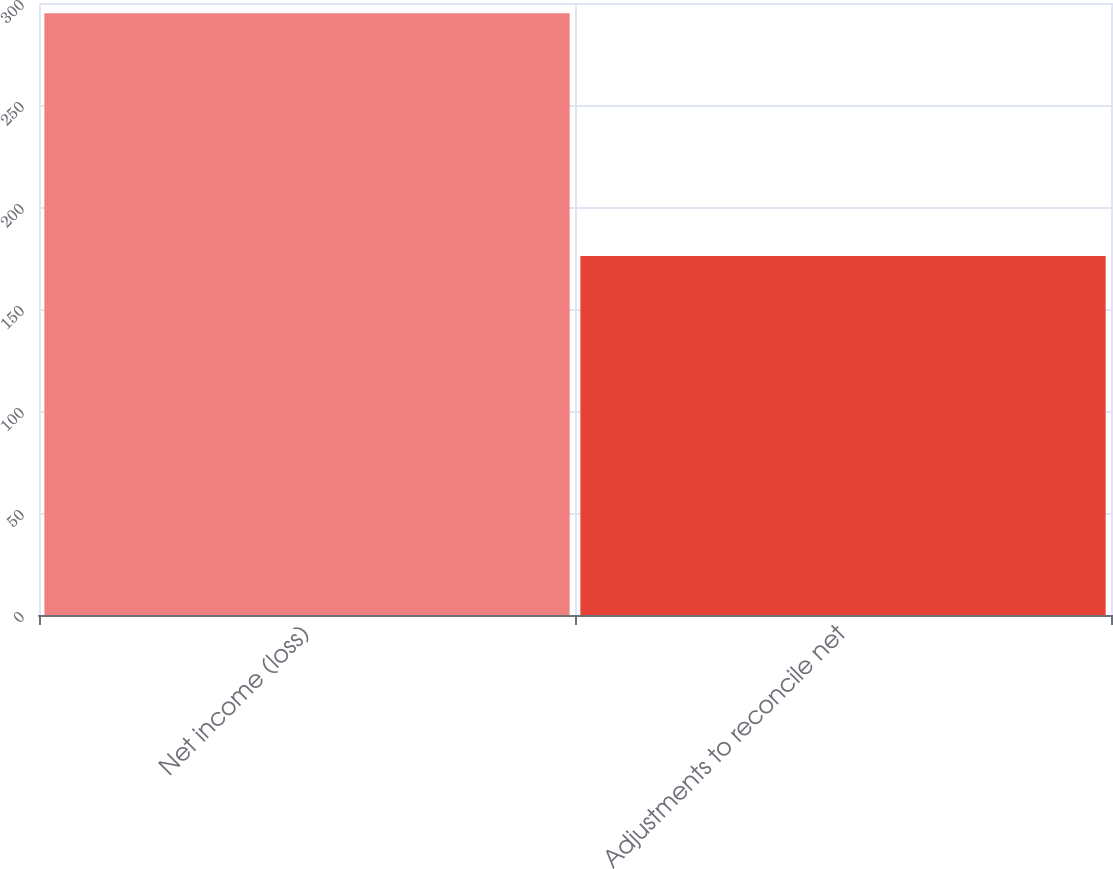Convert chart to OTSL. <chart><loc_0><loc_0><loc_500><loc_500><bar_chart><fcel>Net income (loss)<fcel>Adjustments to reconcile net<nl><fcel>295<fcel>176<nl></chart> 